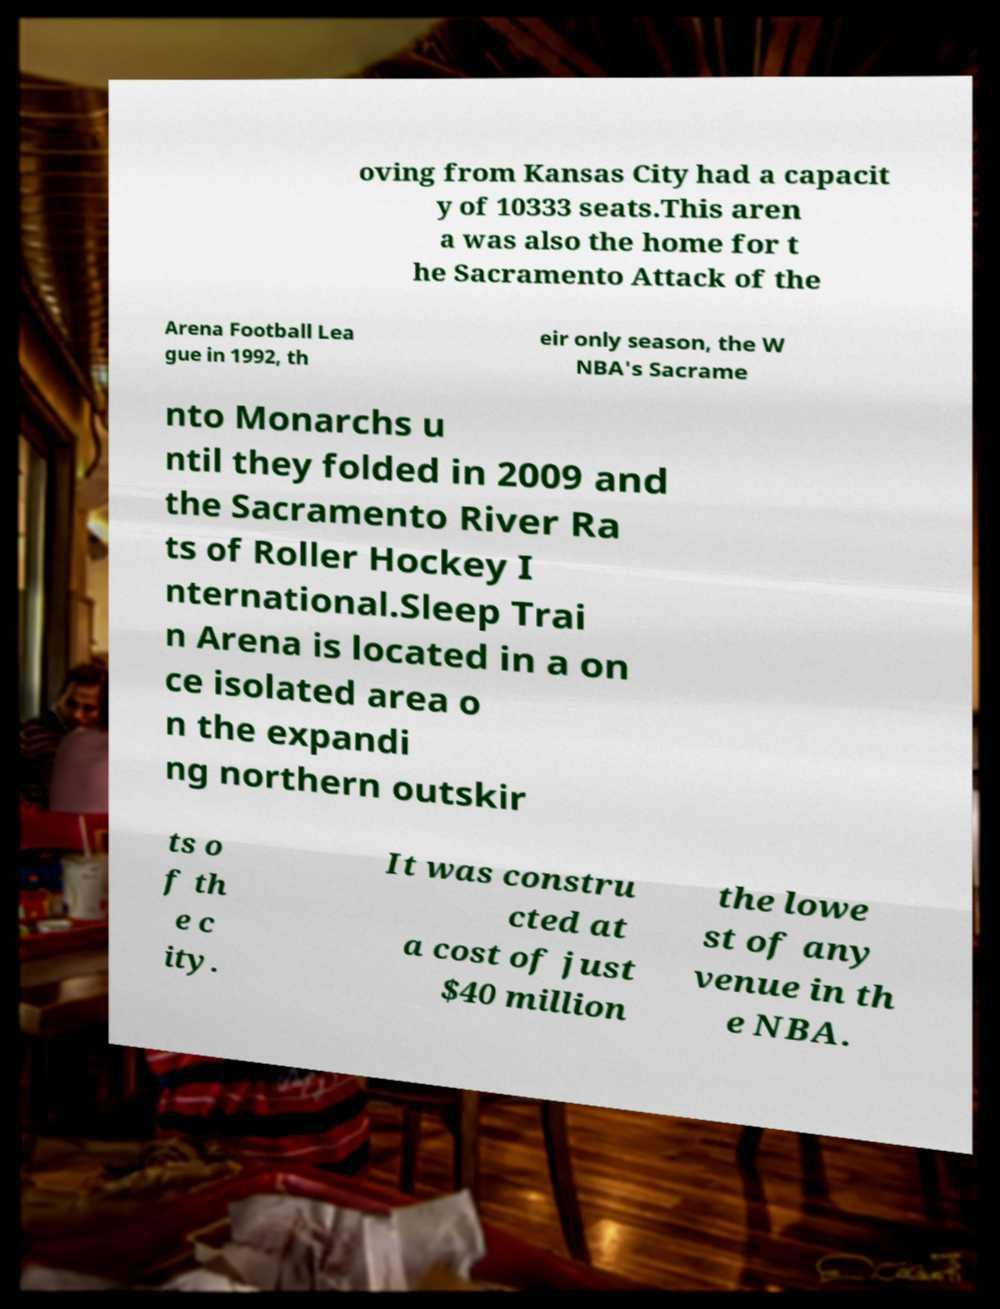Please identify and transcribe the text found in this image. oving from Kansas City had a capacit y of 10333 seats.This aren a was also the home for t he Sacramento Attack of the Arena Football Lea gue in 1992, th eir only season, the W NBA's Sacrame nto Monarchs u ntil they folded in 2009 and the Sacramento River Ra ts of Roller Hockey I nternational.Sleep Trai n Arena is located in a on ce isolated area o n the expandi ng northern outskir ts o f th e c ity. It was constru cted at a cost of just $40 million the lowe st of any venue in th e NBA. 